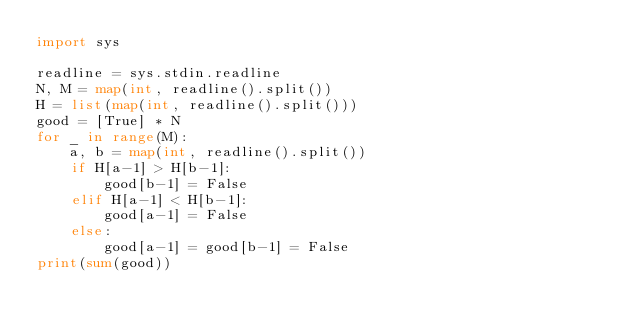<code> <loc_0><loc_0><loc_500><loc_500><_Python_>import sys

readline = sys.stdin.readline
N, M = map(int, readline().split())
H = list(map(int, readline().split()))
good = [True] * N
for _ in range(M):
    a, b = map(int, readline().split())
    if H[a-1] > H[b-1]:
        good[b-1] = False
    elif H[a-1] < H[b-1]:
        good[a-1] = False
    else:
        good[a-1] = good[b-1] = False
print(sum(good))
</code> 